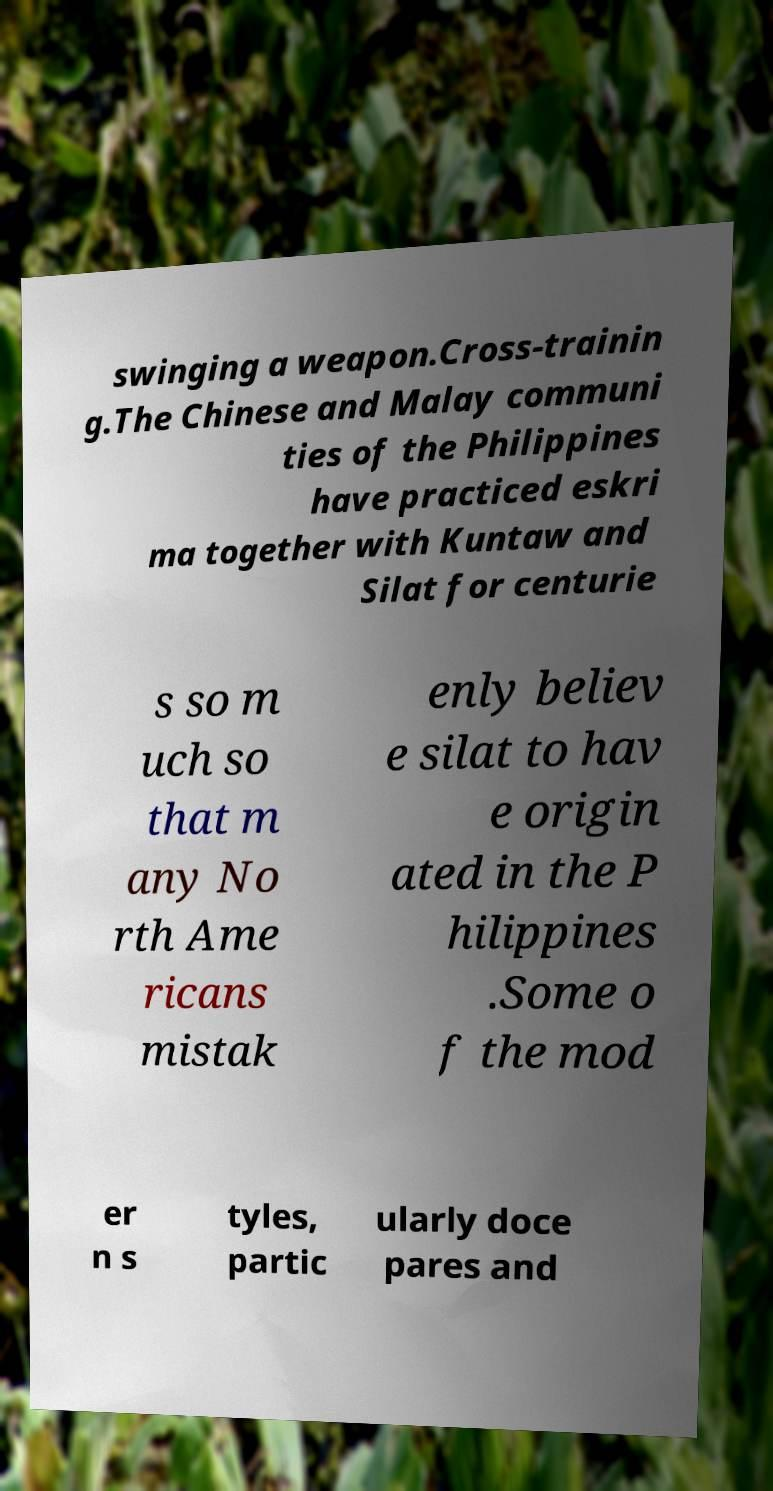There's text embedded in this image that I need extracted. Can you transcribe it verbatim? swinging a weapon.Cross-trainin g.The Chinese and Malay communi ties of the Philippines have practiced eskri ma together with Kuntaw and Silat for centurie s so m uch so that m any No rth Ame ricans mistak enly believ e silat to hav e origin ated in the P hilippines .Some o f the mod er n s tyles, partic ularly doce pares and 